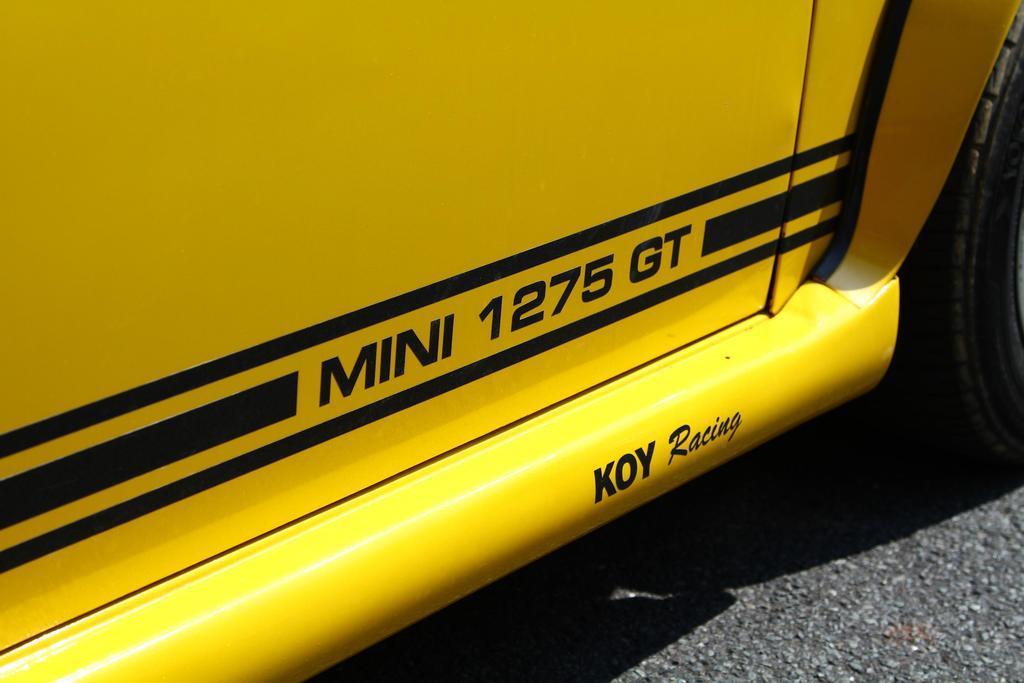How would you summarize this image in a sentence or two? The picture consists of a yellow color vehicle. In the center of the picture it is text. On the right there is a tyre. At the bottom there is road. 